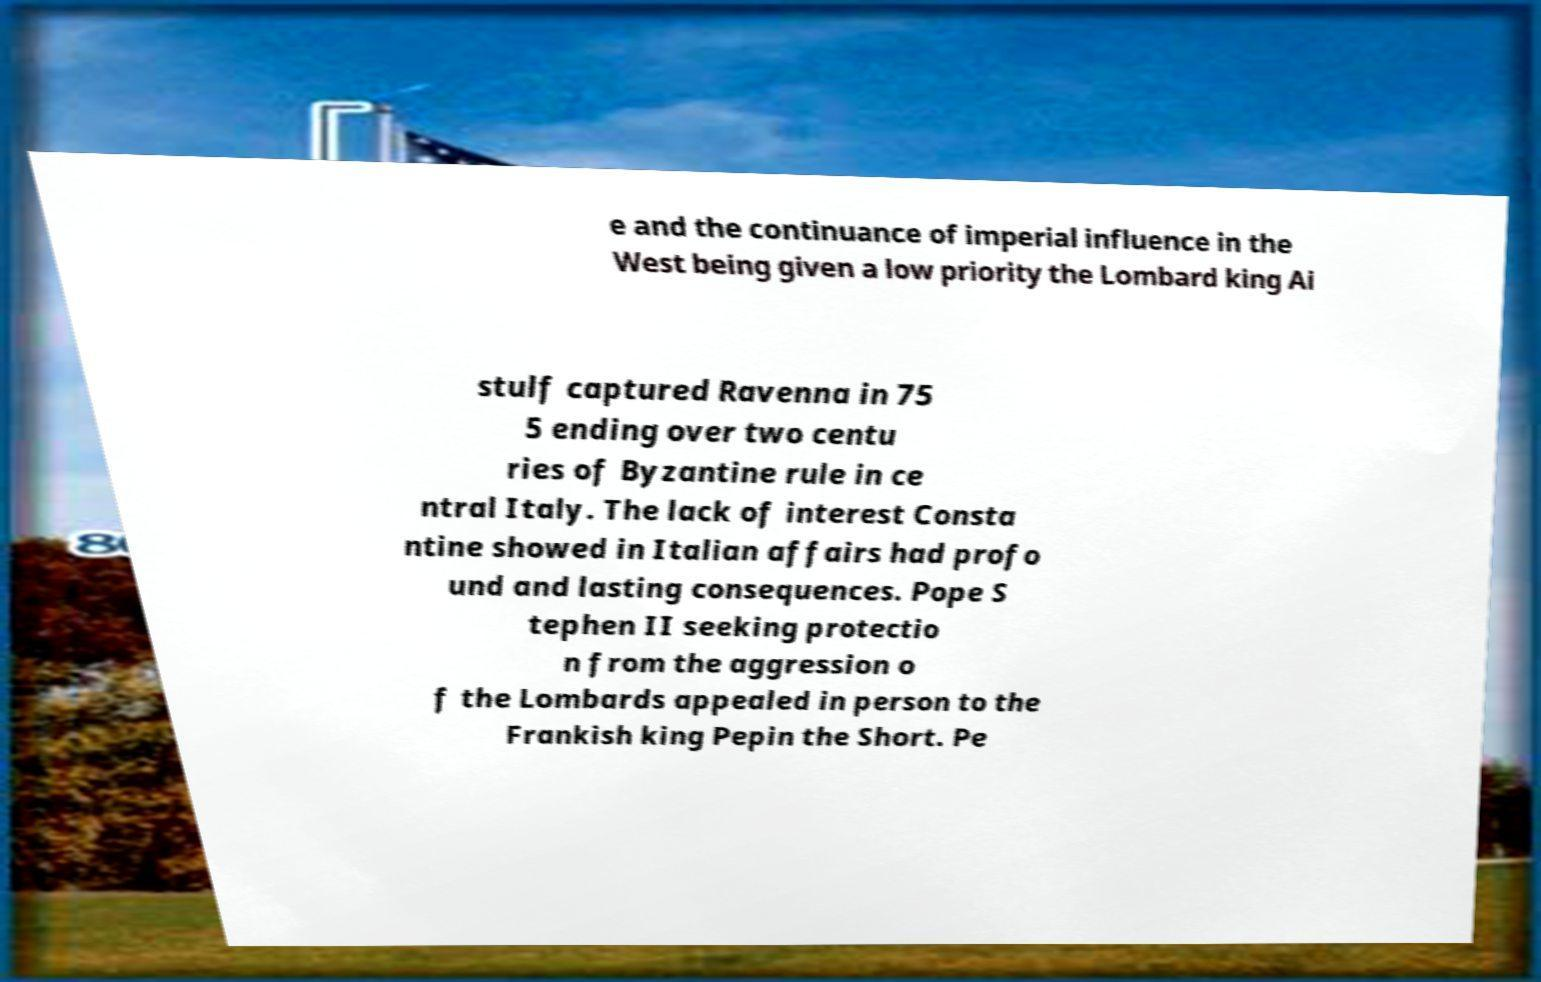I need the written content from this picture converted into text. Can you do that? e and the continuance of imperial influence in the West being given a low priority the Lombard king Ai stulf captured Ravenna in 75 5 ending over two centu ries of Byzantine rule in ce ntral Italy. The lack of interest Consta ntine showed in Italian affairs had profo und and lasting consequences. Pope S tephen II seeking protectio n from the aggression o f the Lombards appealed in person to the Frankish king Pepin the Short. Pe 